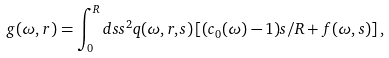Convert formula to latex. <formula><loc_0><loc_0><loc_500><loc_500>g ( \omega , r ) = \int _ { 0 } ^ { R } d s s ^ { 2 } q ( \omega , r , s ) \left [ ( c _ { 0 } ( \omega ) - 1 ) s / R + f ( \omega , s ) \right ] ,</formula> 